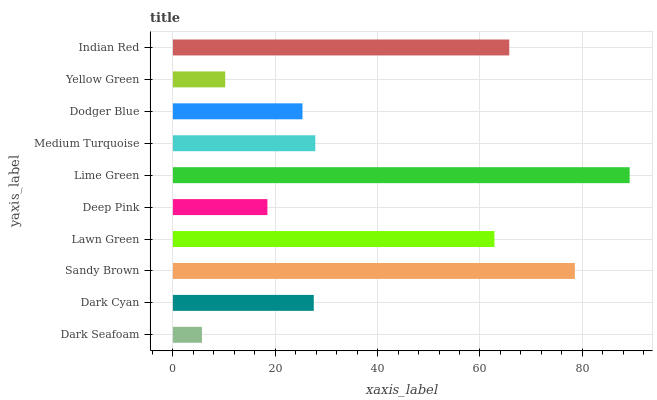Is Dark Seafoam the minimum?
Answer yes or no. Yes. Is Lime Green the maximum?
Answer yes or no. Yes. Is Dark Cyan the minimum?
Answer yes or no. No. Is Dark Cyan the maximum?
Answer yes or no. No. Is Dark Cyan greater than Dark Seafoam?
Answer yes or no. Yes. Is Dark Seafoam less than Dark Cyan?
Answer yes or no. Yes. Is Dark Seafoam greater than Dark Cyan?
Answer yes or no. No. Is Dark Cyan less than Dark Seafoam?
Answer yes or no. No. Is Medium Turquoise the high median?
Answer yes or no. Yes. Is Dark Cyan the low median?
Answer yes or no. Yes. Is Lawn Green the high median?
Answer yes or no. No. Is Lawn Green the low median?
Answer yes or no. No. 